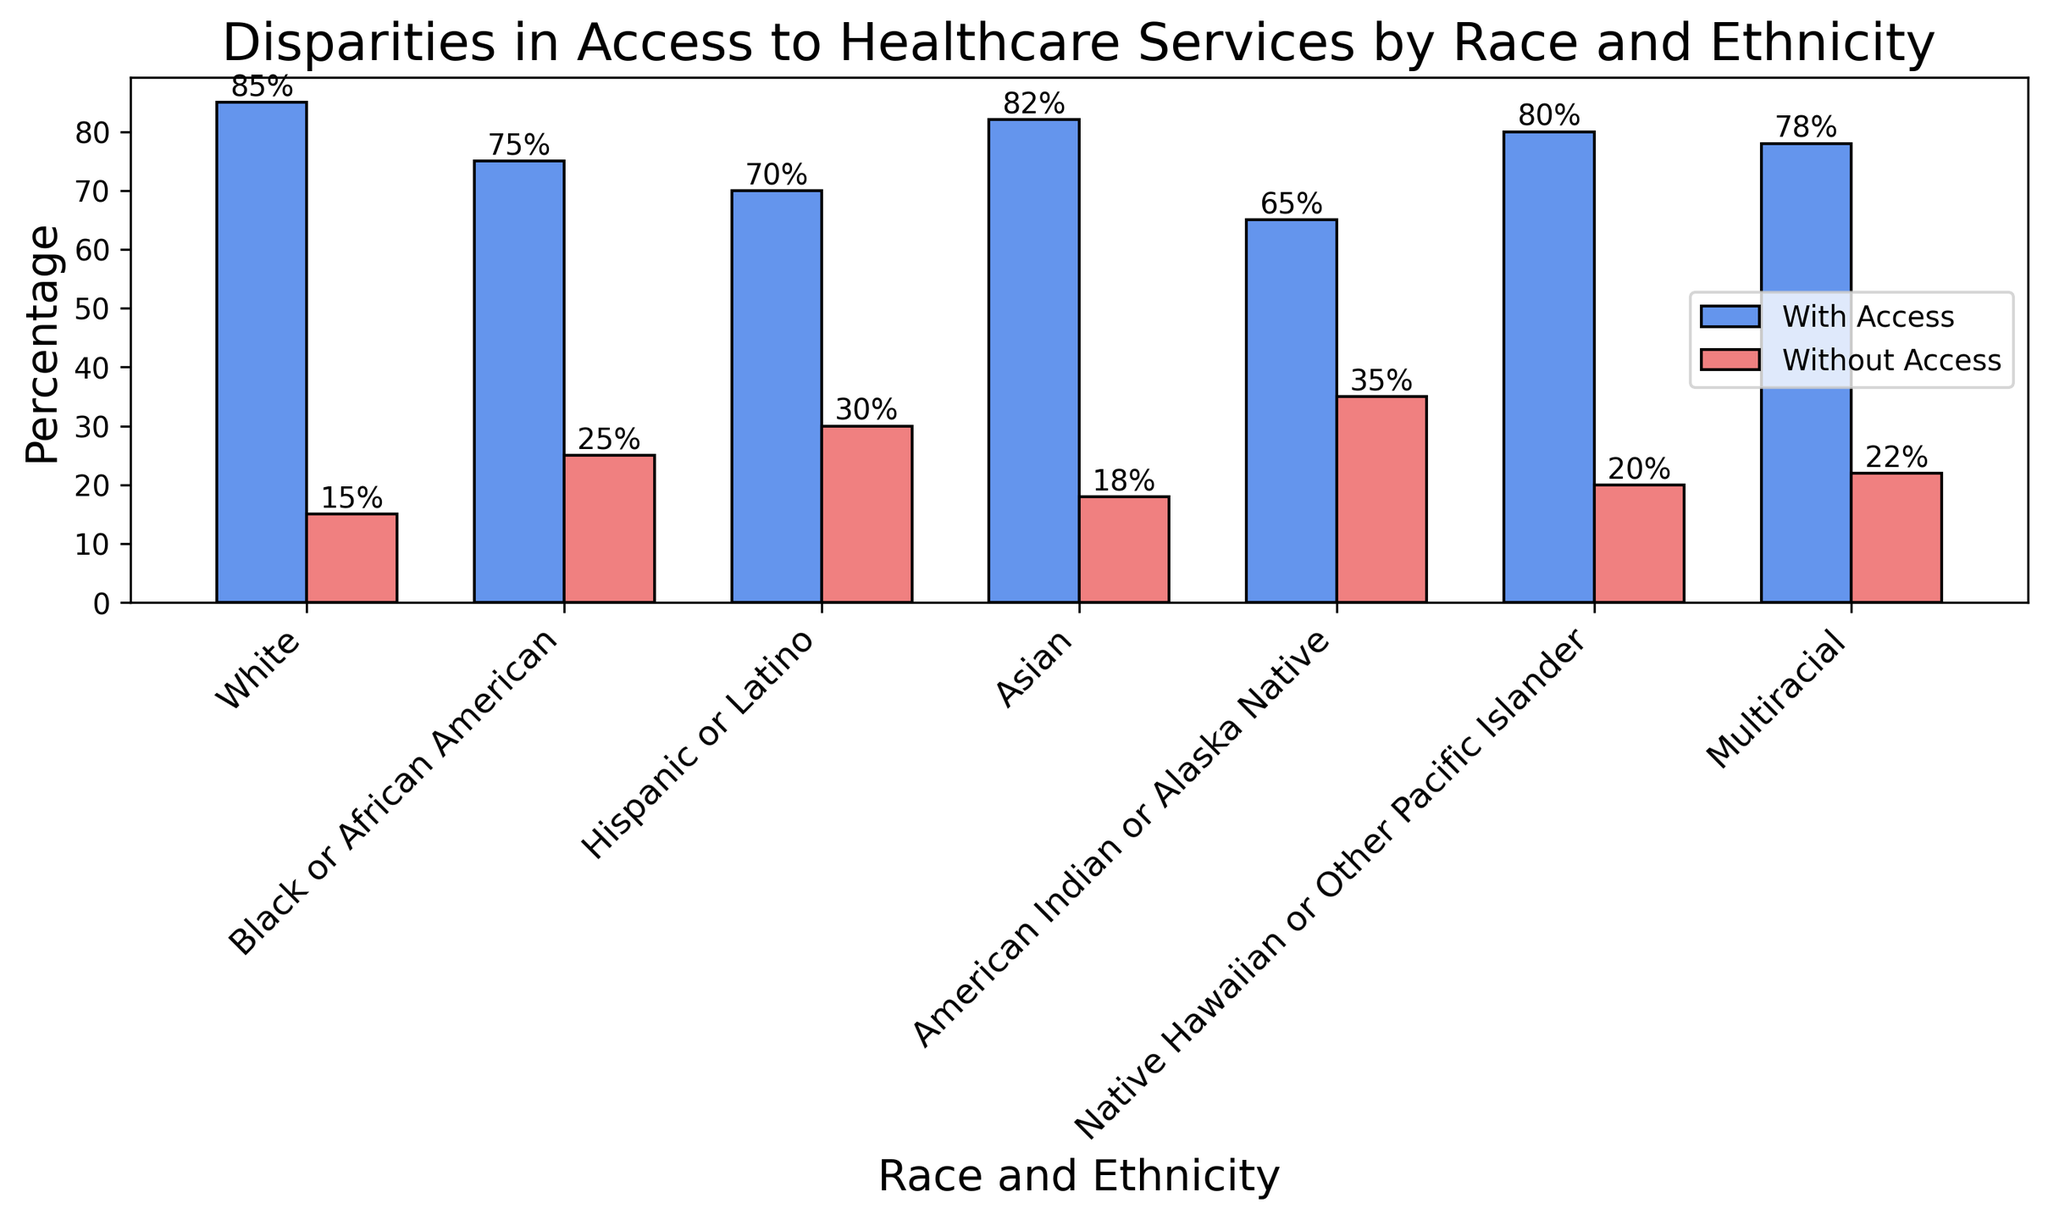What percentage of White individuals have access to healthcare services? The bar labeled "White" shows the height of the bar for "PercentageWithAccess" as 85%.
Answer: 85% Which racial or ethnic group has the highest percentage without access to healthcare services? By comparing the heights of the bars labeled "Without Access", the "American Indian or Alaska Native" group has the highest bar at 35%.
Answer: American Indian or Alaska Native How does the percentage of Hispanic or Latino individuals without access to healthcare compare to those with access? For Hispanic or Latino individuals, the percentage with access is 70%, while the percentage without access is 30%. The difference is 70% - 30% = 40%.
Answer: 40% more have access Is there any group where the percentage with access is equal to the percentage without access? Reviewing all bars, none of the racial or ethnic groups have equal heights for "PercentageWithAccess" and "PercentageWithoutAccess".
Answer: No Which group has the smallest disparity between access and non-access to healthcare services? Calculate the absolute differences for each group:
- White: 85% - 15% = 70%
- Black or African American: 75% - 25% = 50%
- Hispanic or Latino: 70% - 30% = 40%
- Asian: 82% - 18% = 64%
- American Indian or Alaska Native: 65% - 35% = 30%
- Native Hawaiian or Other Pacific Islander: 80% - 20% = 60%
- Multiracial: 78% - 22% = 56%
The smallest disparity is for the American Indian or Alaska Native group at 30%.
Answer: American Indian or Alaska Native What is the average percentage without access to healthcare services across all racial and ethnic groups? Sum all the percentages without access and divide by the number of groups:
(15% + 25% + 30% + 18% + 35% + 20% + 22%) / 7 ≈ 23.57%
Answer: 23.57% Compare the access to healthcare services between Black or African American and Multiracial individuals. - Black or African American with access: 75%
- Multiracial with access: 78%
- Black or African American without access: 25%
- Multiracial without access: 22%
Both racial groups have similar percentages but Multiracial has slightly higher access and lower non-access.
Answer: Multiracial has slightly higher access What is the visual difference in heights of the bars for the percentage with access between Asian and Native Hawaiian or Other Pacific Islander groups? The bar for Asian (82%) is slightly taller than the bar for Native Hawaiian or Other Pacific Islander (80%) in "PercentageWithAccess".
Answer: Asian is slightly taller 